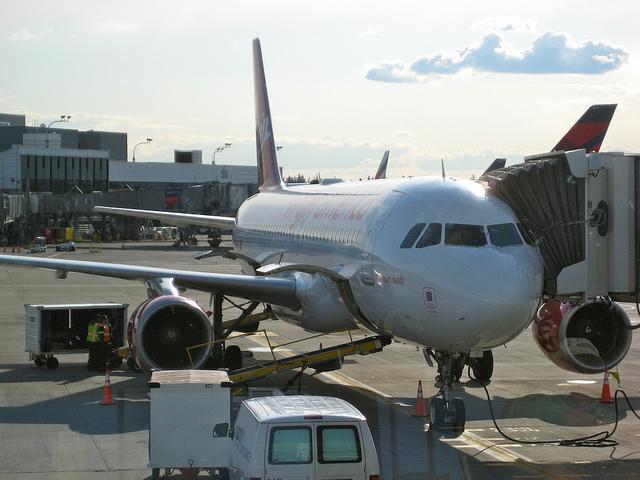How many engines are on this plane?
Give a very brief answer. 2. How many trucks are there?
Give a very brief answer. 2. How many cake clouds are there?
Give a very brief answer. 0. 